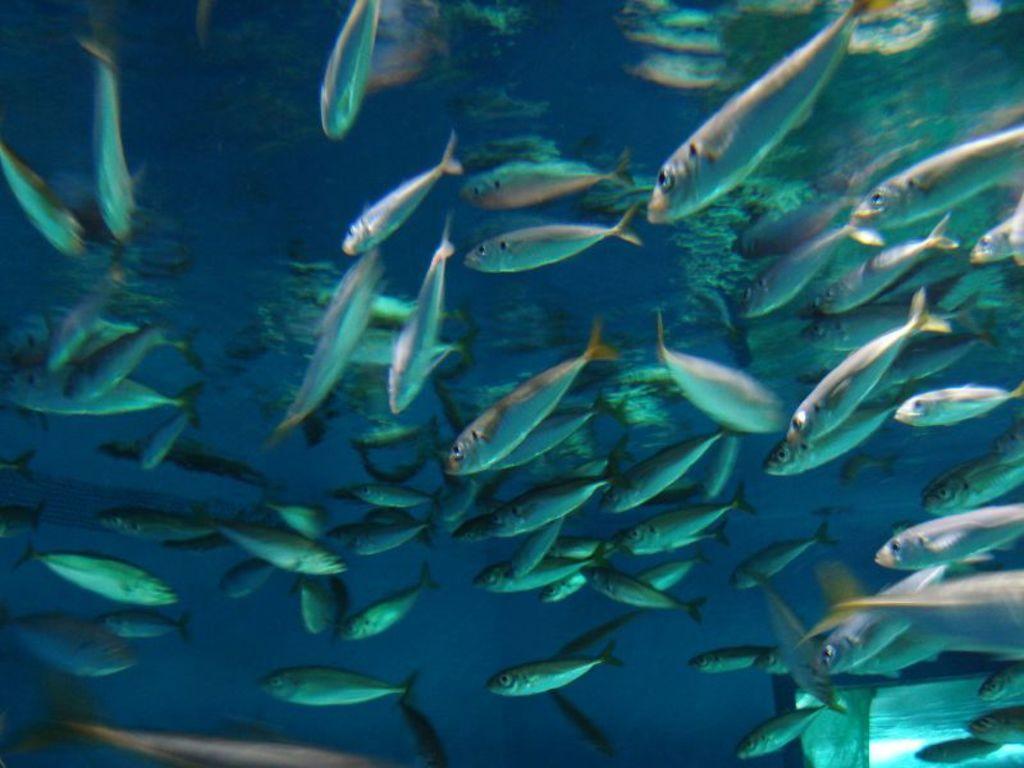Could you give a brief overview of what you see in this image? In this image, we can see fishes in the water. 